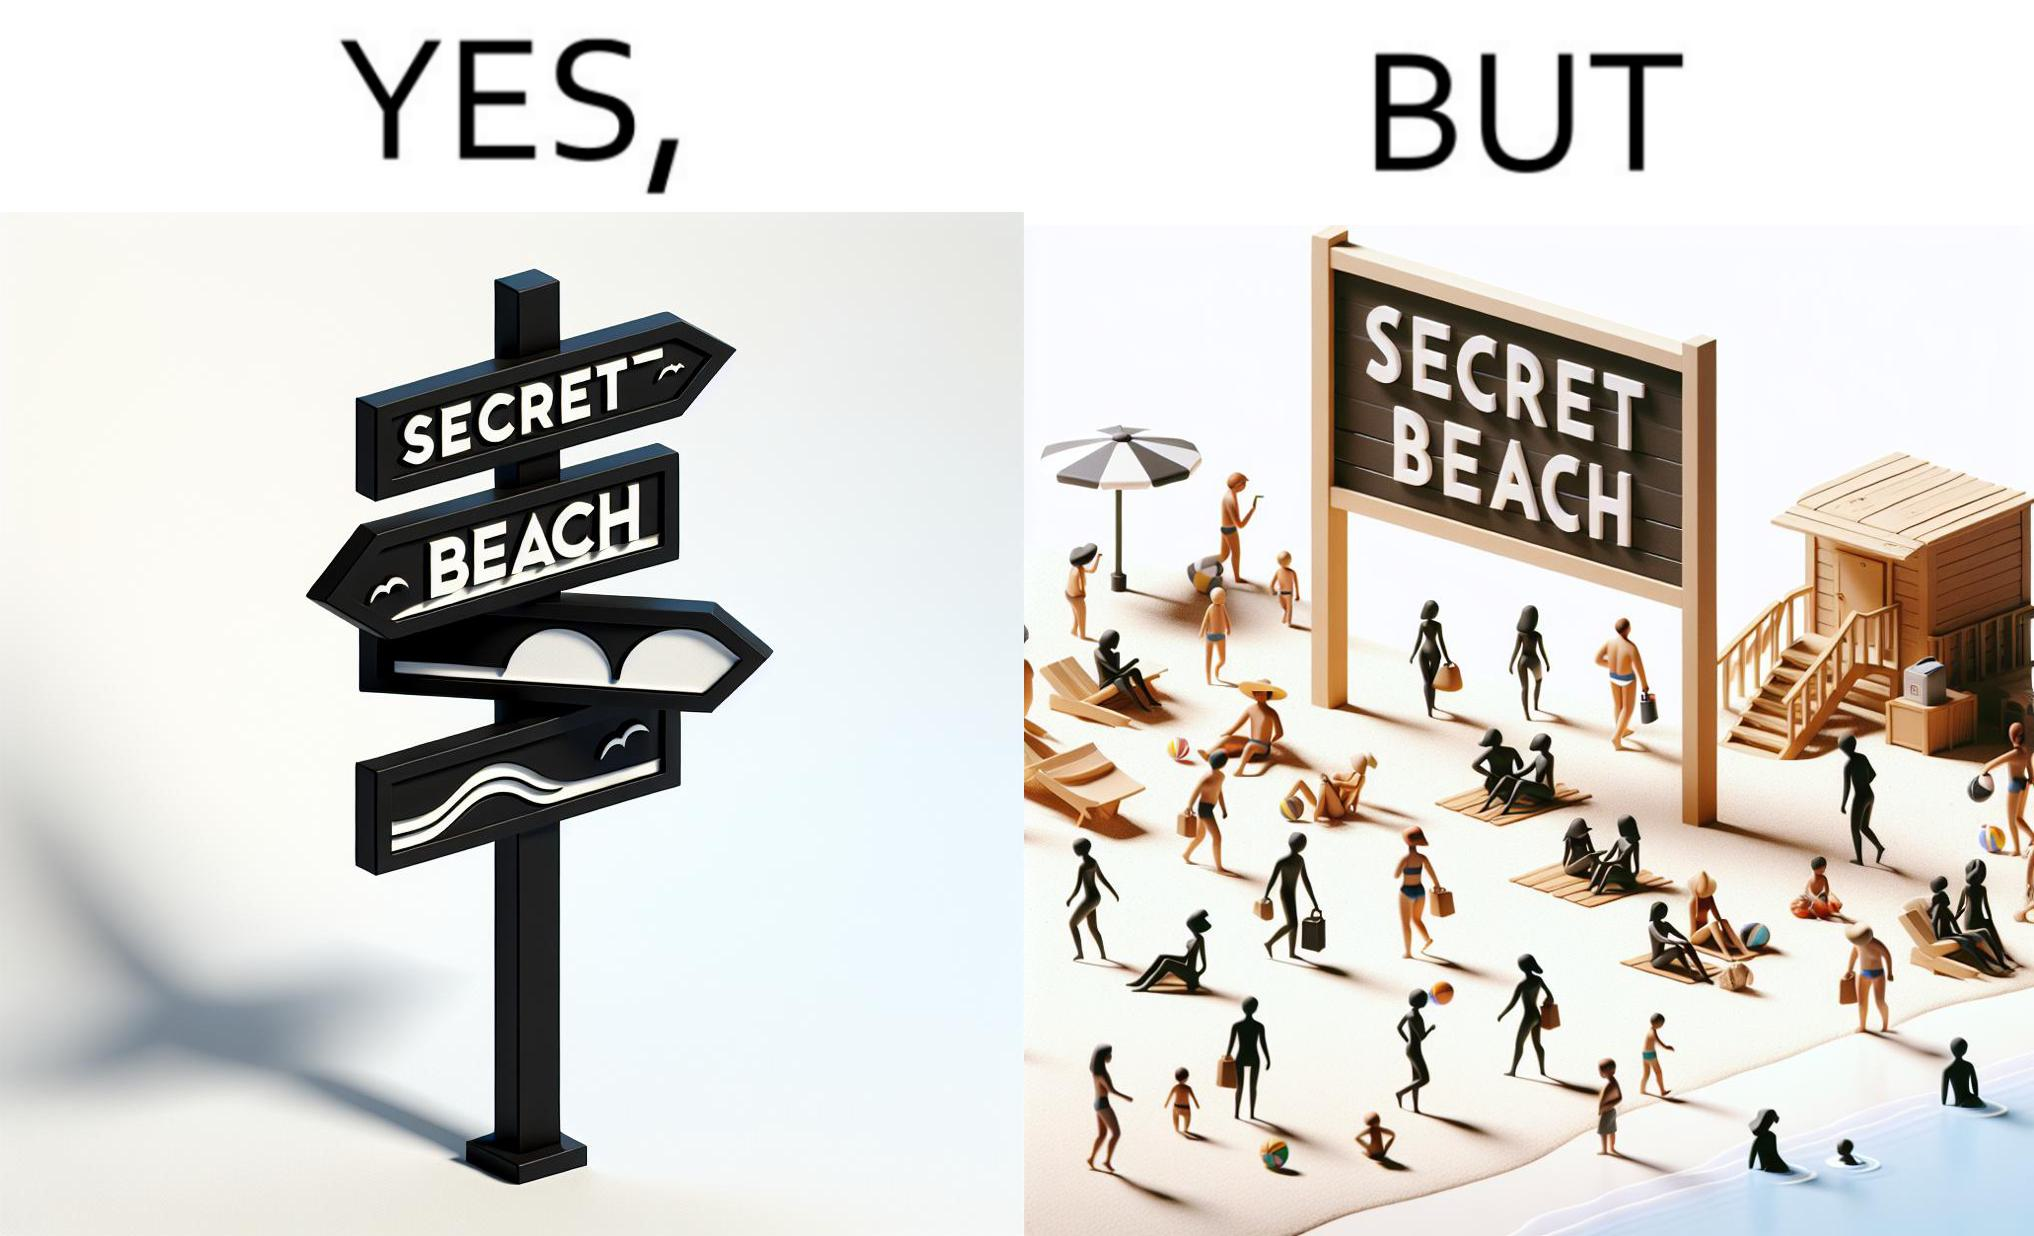What do you see in each half of this image? In the left part of the image: A board with "Secret Beach" written on it. In the right part of the image: People in a beach, having a board with "Secret Beach" written on it at its entrance. 